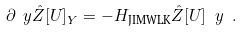Convert formula to latex. <formula><loc_0><loc_0><loc_500><loc_500>\partial _ { \ } y \hat { Z } [ U ] _ { Y } = - H _ { \text {JIMWLK} } \hat { Z } [ U ] _ { \ } y \ .</formula> 